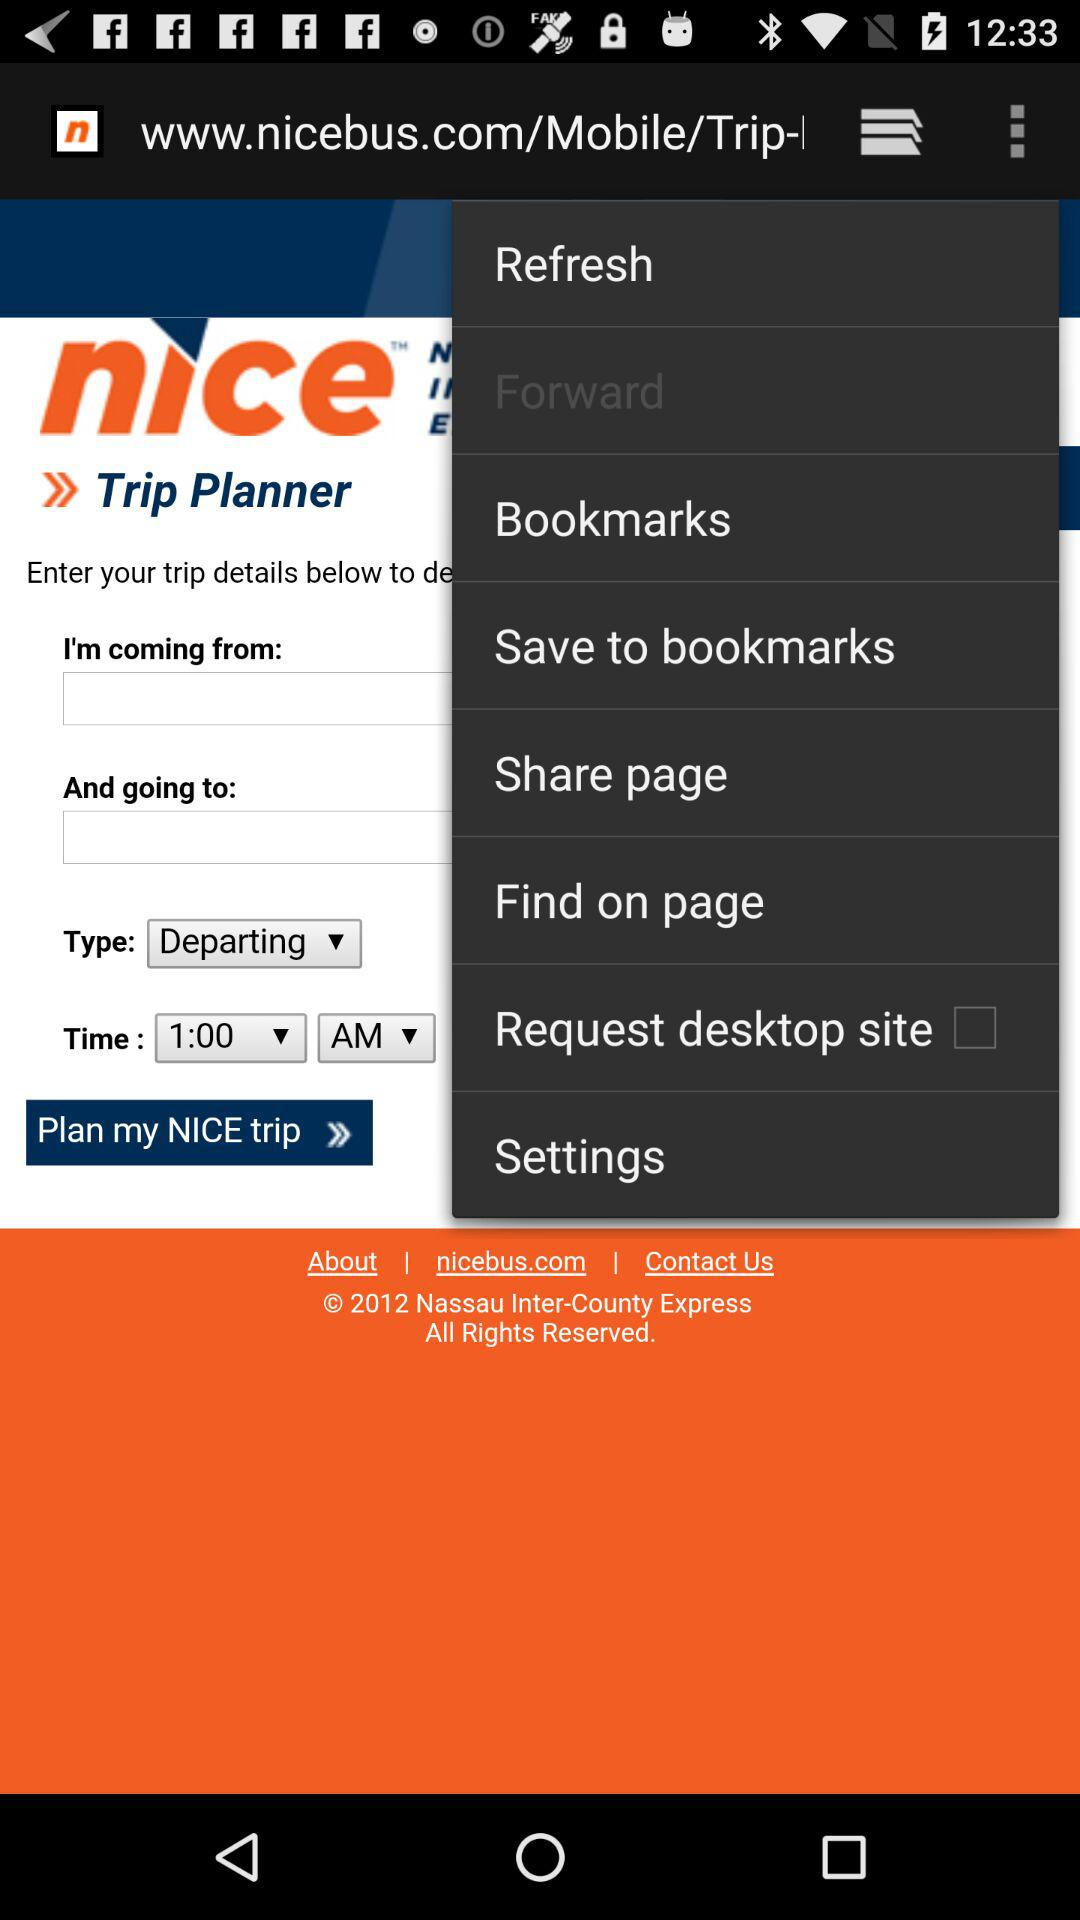What is the status of the "Request desktop site"? The status of the "Request desktop site" is "off". 